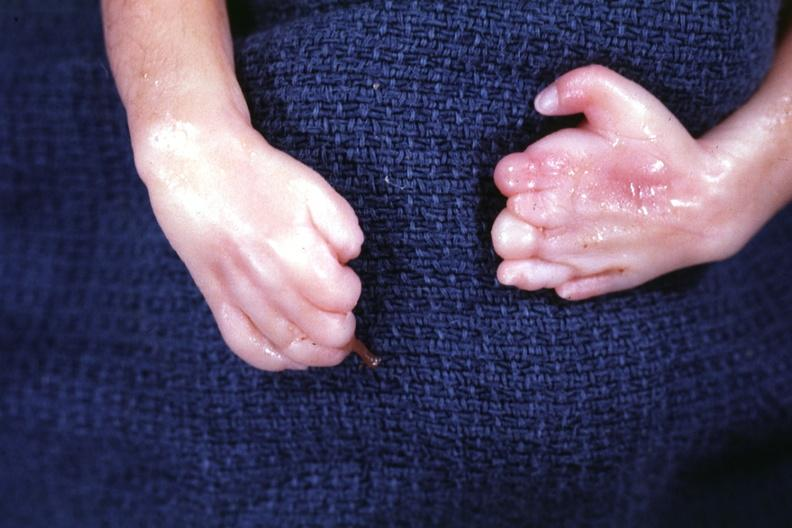what are present?
Answer the question using a single word or phrase. Extremities 